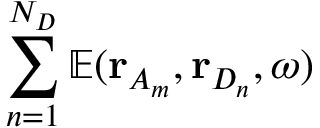<formula> <loc_0><loc_0><loc_500><loc_500>\sum _ { n = 1 } ^ { N _ { D } } \mathbb { E } ( r _ { A _ { m } } , r _ { D _ { n } } , \omega )</formula> 